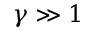Convert formula to latex. <formula><loc_0><loc_0><loc_500><loc_500>\gamma \gg 1</formula> 